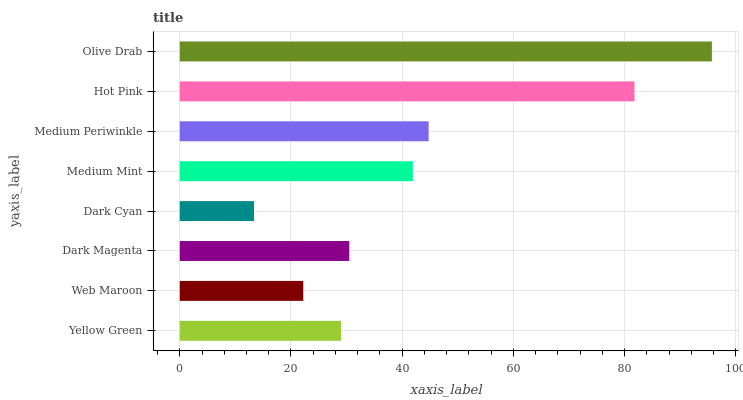Is Dark Cyan the minimum?
Answer yes or no. Yes. Is Olive Drab the maximum?
Answer yes or no. Yes. Is Web Maroon the minimum?
Answer yes or no. No. Is Web Maroon the maximum?
Answer yes or no. No. Is Yellow Green greater than Web Maroon?
Answer yes or no. Yes. Is Web Maroon less than Yellow Green?
Answer yes or no. Yes. Is Web Maroon greater than Yellow Green?
Answer yes or no. No. Is Yellow Green less than Web Maroon?
Answer yes or no. No. Is Medium Mint the high median?
Answer yes or no. Yes. Is Dark Magenta the low median?
Answer yes or no. Yes. Is Hot Pink the high median?
Answer yes or no. No. Is Medium Mint the low median?
Answer yes or no. No. 